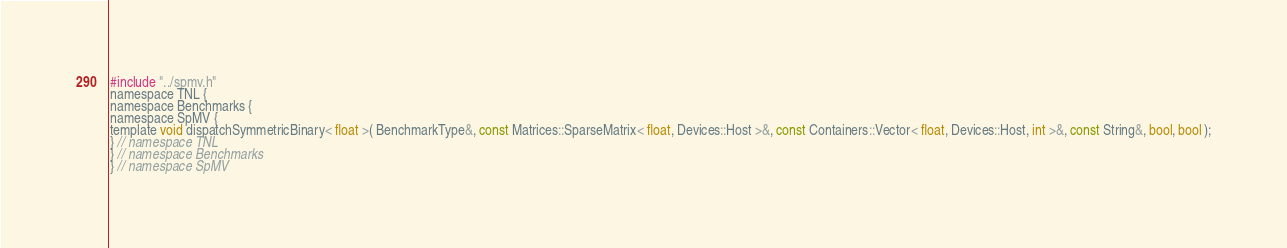Convert code to text. <code><loc_0><loc_0><loc_500><loc_500><_Cuda_>#include "../spmv.h"
namespace TNL {
namespace Benchmarks {
namespace SpMV {
template void dispatchSymmetricBinary< float >( BenchmarkType&, const Matrices::SparseMatrix< float, Devices::Host >&, const Containers::Vector< float, Devices::Host, int >&, const String&, bool, bool );
} // namespace TNL
} // namespace Benchmarks
} // namespace SpMV
</code> 